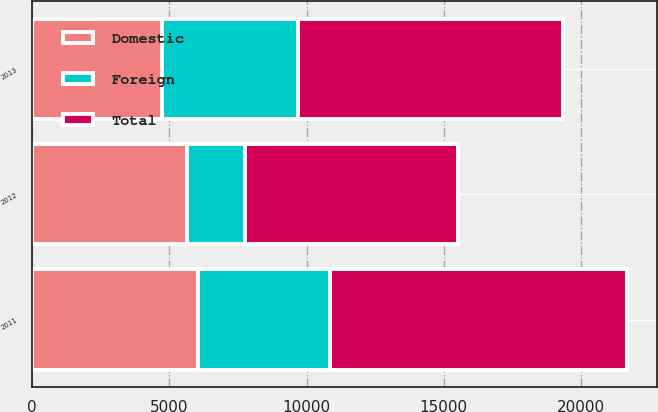<chart> <loc_0><loc_0><loc_500><loc_500><stacked_bar_chart><ecel><fcel>2013<fcel>2012<fcel>2011<nl><fcel>Foreign<fcel>4930<fcel>2117<fcel>4806<nl><fcel>Domestic<fcel>4747<fcel>5636<fcel>6035<nl><fcel>Total<fcel>9677<fcel>7753<fcel>10841<nl></chart> 